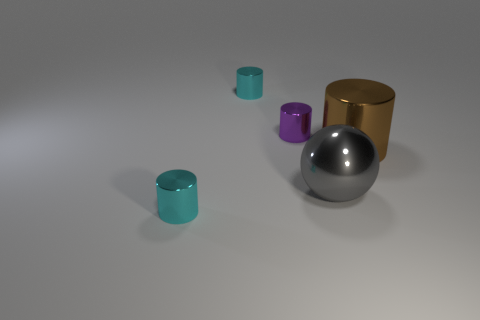How big is the purple shiny cylinder? The purple cylinder is comparatively small, with a height that appears to be about one-third of the golden cylinder next to it, and a diameter slightly less than its height. 